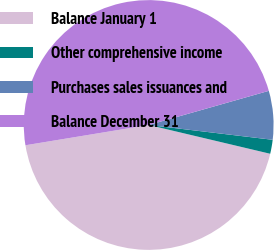Convert chart to OTSL. <chart><loc_0><loc_0><loc_500><loc_500><pie_chart><fcel>Balance January 1<fcel>Other comprehensive income<fcel>Purchases sales issuances and<fcel>Balance December 31<nl><fcel>43.7%<fcel>1.81%<fcel>6.3%<fcel>48.19%<nl></chart> 